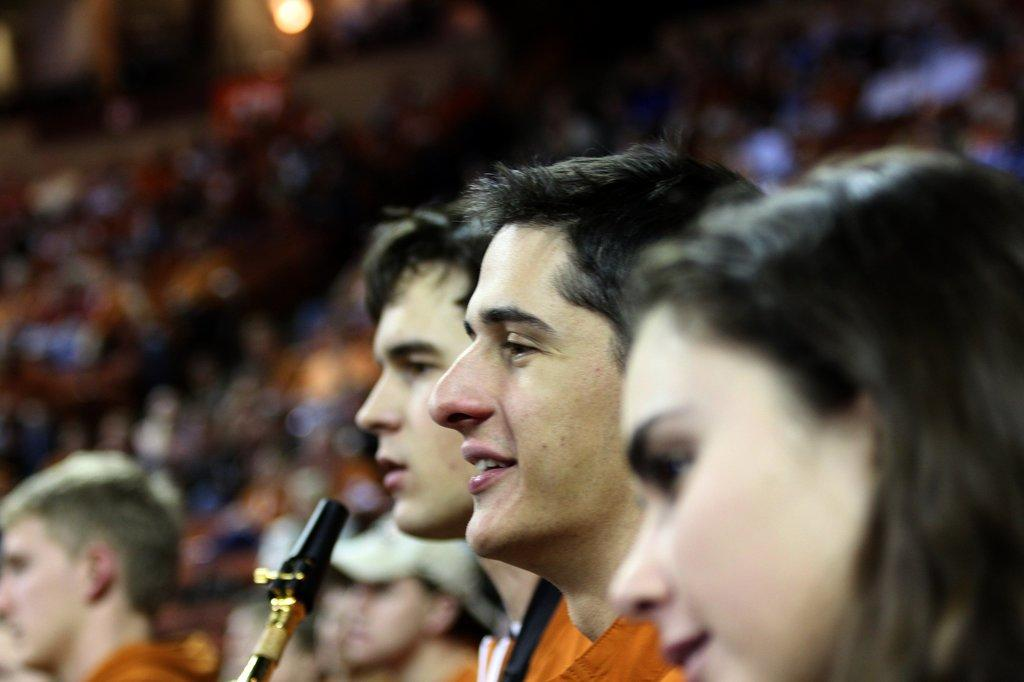Who or what can be seen in the image? There are people in the image. What object is present that is typically used for amplifying sound? There is a microphone (mic) in the image. Can you describe the people in the background of the image? There is a group of people in the background of the image. What can be seen that indicates the presence of light? There is light visible in the image. How would you describe the quality of the image? The image is blurry. What type of needle is being used to sew peace in the image? There is no needle or sewing activity present in the image. What territory is being claimed by the people in the image? There is no indication of any territory being claimed in the image. 